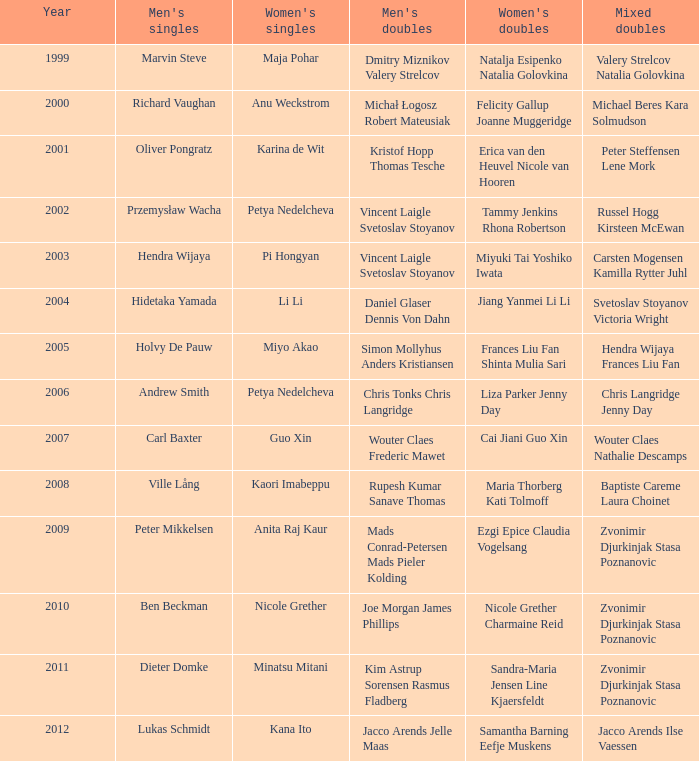When did guo xin make her debut in women's singles? 2007.0. 